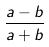<formula> <loc_0><loc_0><loc_500><loc_500>\frac { a - b } { a + b }</formula> 